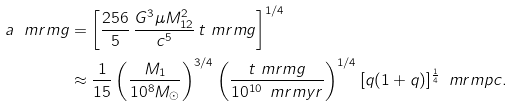Convert formula to latex. <formula><loc_0><loc_0><loc_500><loc_500>a _ { \ } m r m { g } & = \left [ \frac { 2 5 6 } { 5 } \, \frac { G ^ { 3 } \mu M _ { 1 2 } ^ { 2 } } { c ^ { 5 } } \, t _ { \ } m r m { g } \right ] ^ { 1 / 4 } \\ & \approx \frac { 1 } { 1 5 } \left ( \frac { M _ { 1 } } { 1 0 ^ { 8 } M _ { \odot } } \right ) ^ { 3 / 4 } \left ( \frac { t _ { \ } m r m { g } } { 1 0 ^ { 1 0 } \, \ m r m { y r } } \right ) ^ { 1 / 4 } [ q ( 1 + q ) ] ^ { \frac { 1 } { 4 } } \, \ m r m { p c } .</formula> 